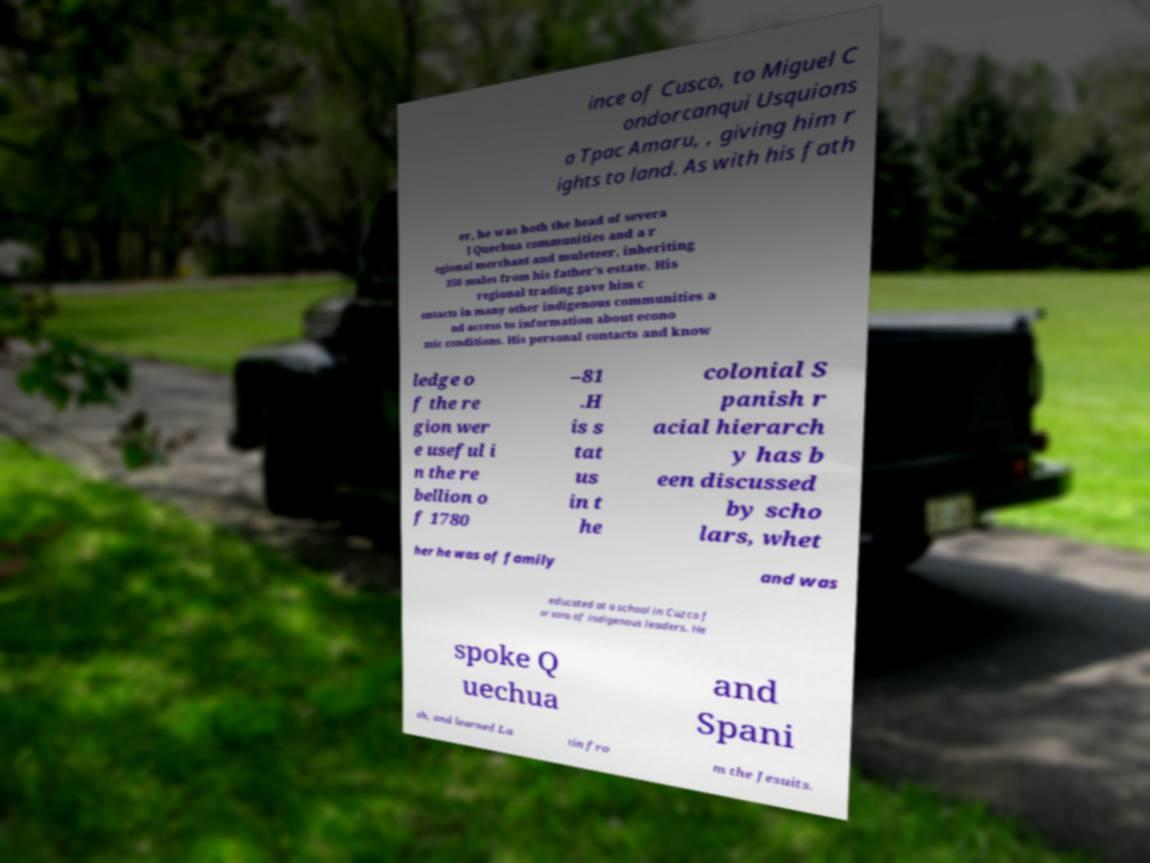What messages or text are displayed in this image? I need them in a readable, typed format. ince of Cusco, to Miguel C ondorcanqui Usquions a Tpac Amaru, , giving him r ights to land. As with his fath er, he was both the head of severa l Quechua communities and a r egional merchant and muleteer, inheriting 350 mules from his father's estate. His regional trading gave him c ontacts in many other indigenous communities a nd access to information about econo mic conditions. His personal contacts and know ledge o f the re gion wer e useful i n the re bellion o f 1780 –81 .H is s tat us in t he colonial S panish r acial hierarch y has b een discussed by scho lars, whet her he was of family and was educated at a school in Cuzco f or sons of indigenous leaders. He spoke Q uechua and Spani sh, and learned La tin fro m the Jesuits. 